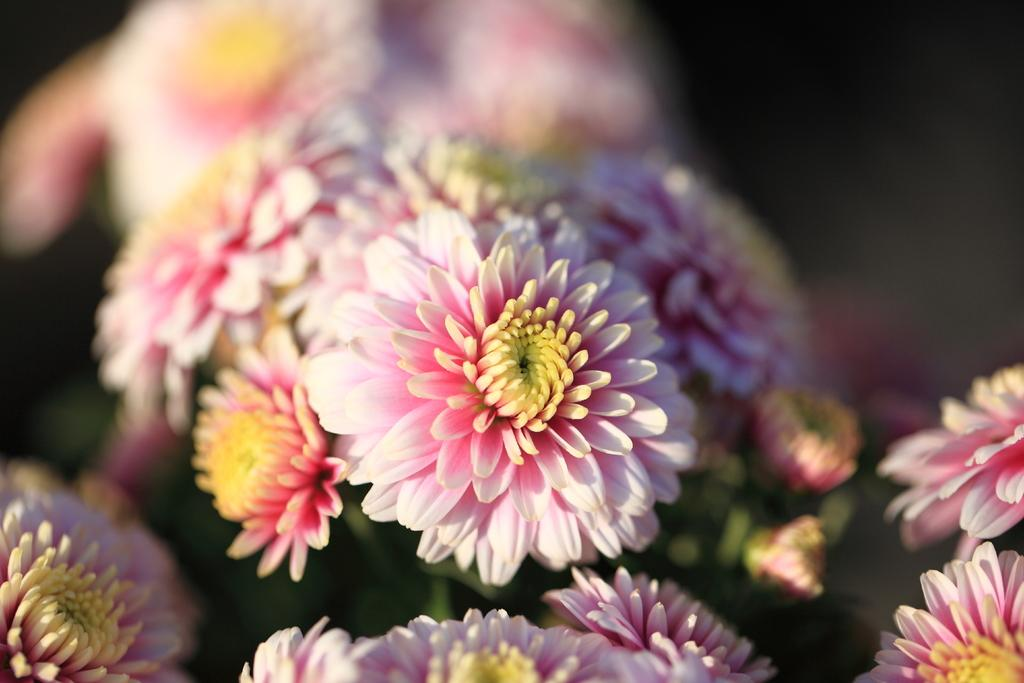What type of plants can be seen in the foreground of the image? There are flowers in the foreground of the image. What type of watch can be seen on the top of the flowers in the image? There is no watch present in the image, and the flowers do not have a top. 